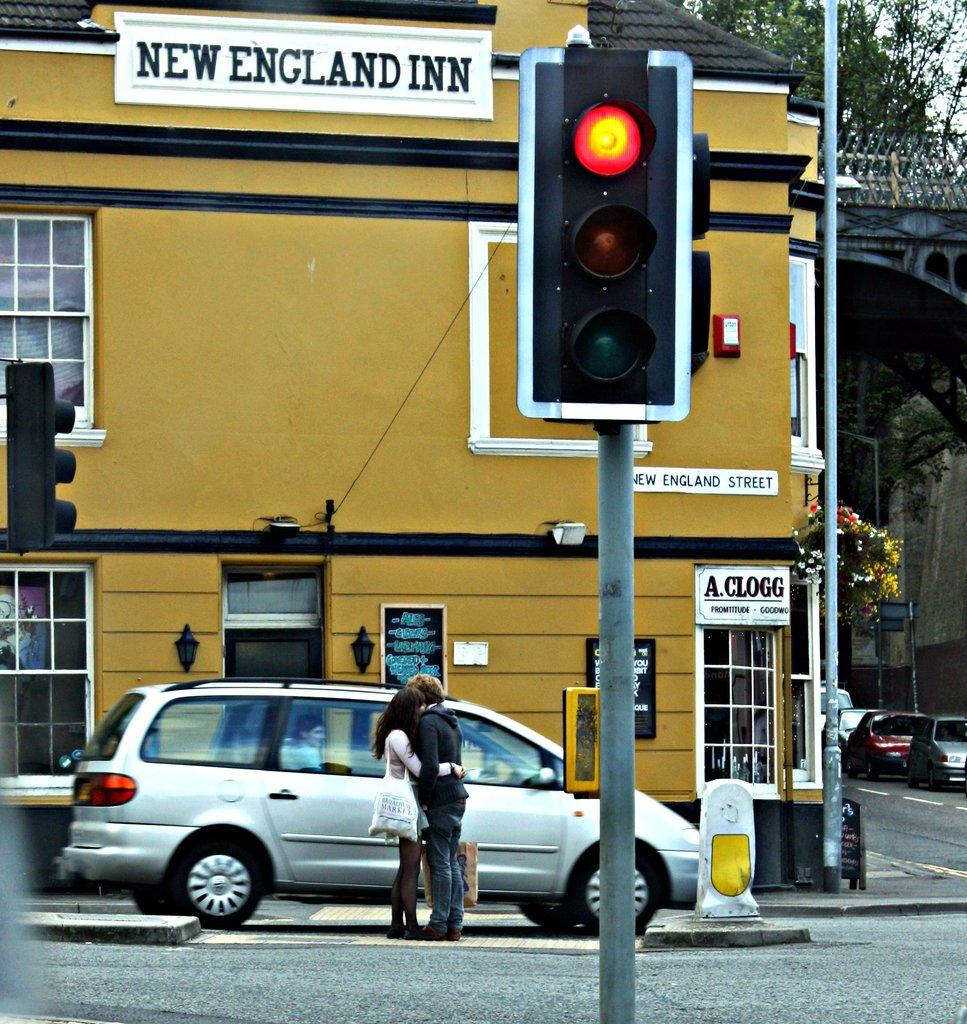<image>
Provide a brief description of the given image. The New England INN is painted a mustard yellow color, with a black roof. 